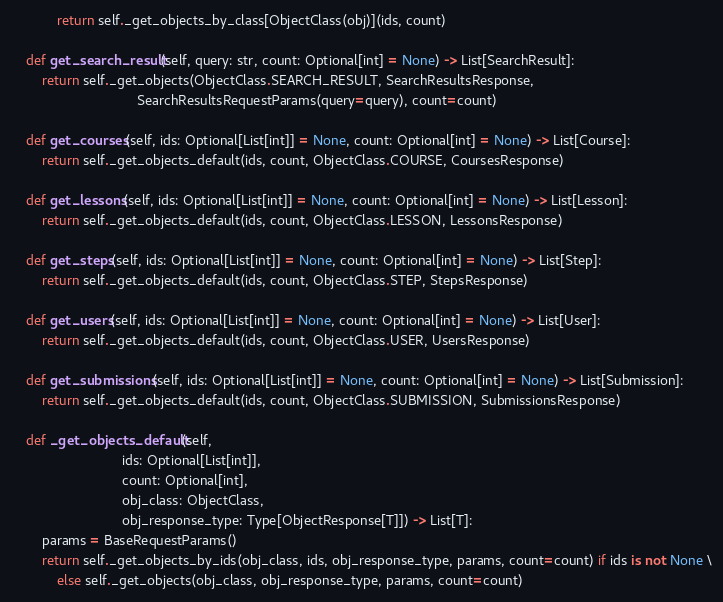<code> <loc_0><loc_0><loc_500><loc_500><_Python_>            return self._get_objects_by_class[ObjectClass(obj)](ids, count)

    def get_search_result(self, query: str, count: Optional[int] = None) -> List[SearchResult]:
        return self._get_objects(ObjectClass.SEARCH_RESULT, SearchResultsResponse,
                                 SearchResultsRequestParams(query=query), count=count)

    def get_courses(self, ids: Optional[List[int]] = None, count: Optional[int] = None) -> List[Course]:
        return self._get_objects_default(ids, count, ObjectClass.COURSE, CoursesResponse)

    def get_lessons(self, ids: Optional[List[int]] = None, count: Optional[int] = None) -> List[Lesson]:
        return self._get_objects_default(ids, count, ObjectClass.LESSON, LessonsResponse)

    def get_steps(self, ids: Optional[List[int]] = None, count: Optional[int] = None) -> List[Step]:
        return self._get_objects_default(ids, count, ObjectClass.STEP, StepsResponse)

    def get_users(self, ids: Optional[List[int]] = None, count: Optional[int] = None) -> List[User]:
        return self._get_objects_default(ids, count, ObjectClass.USER, UsersResponse)

    def get_submissions(self, ids: Optional[List[int]] = None, count: Optional[int] = None) -> List[Submission]:
        return self._get_objects_default(ids, count, ObjectClass.SUBMISSION, SubmissionsResponse)

    def _get_objects_default(self,
                             ids: Optional[List[int]],
                             count: Optional[int],
                             obj_class: ObjectClass,
                             obj_response_type: Type[ObjectResponse[T]]) -> List[T]:
        params = BaseRequestParams()
        return self._get_objects_by_ids(obj_class, ids, obj_response_type, params, count=count) if ids is not None \
            else self._get_objects(obj_class, obj_response_type, params, count=count)
</code> 